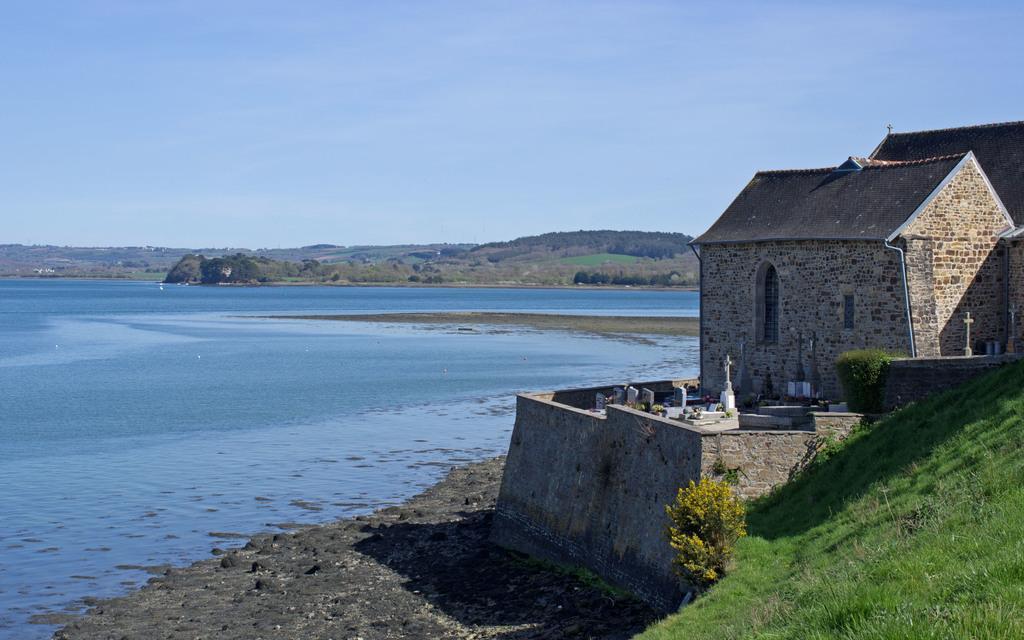Describe this image in one or two sentences. On the right side of the image on the ground there is grass. And also there is a building with walls, roofs and windows. Beside the house there are graves. And also there is a wall. And in the image there is water. Behind the water there are trees. At the top of the image there is sky. 